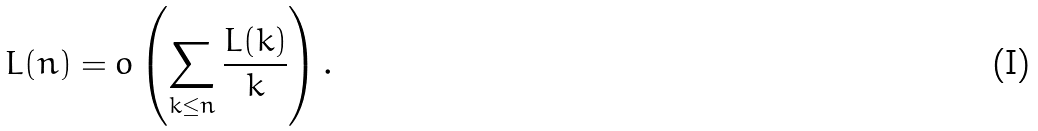<formula> <loc_0><loc_0><loc_500><loc_500>L ( n ) = o \left ( \sum _ { k \leq n } \frac { L ( k ) } { k } \right ) .</formula> 